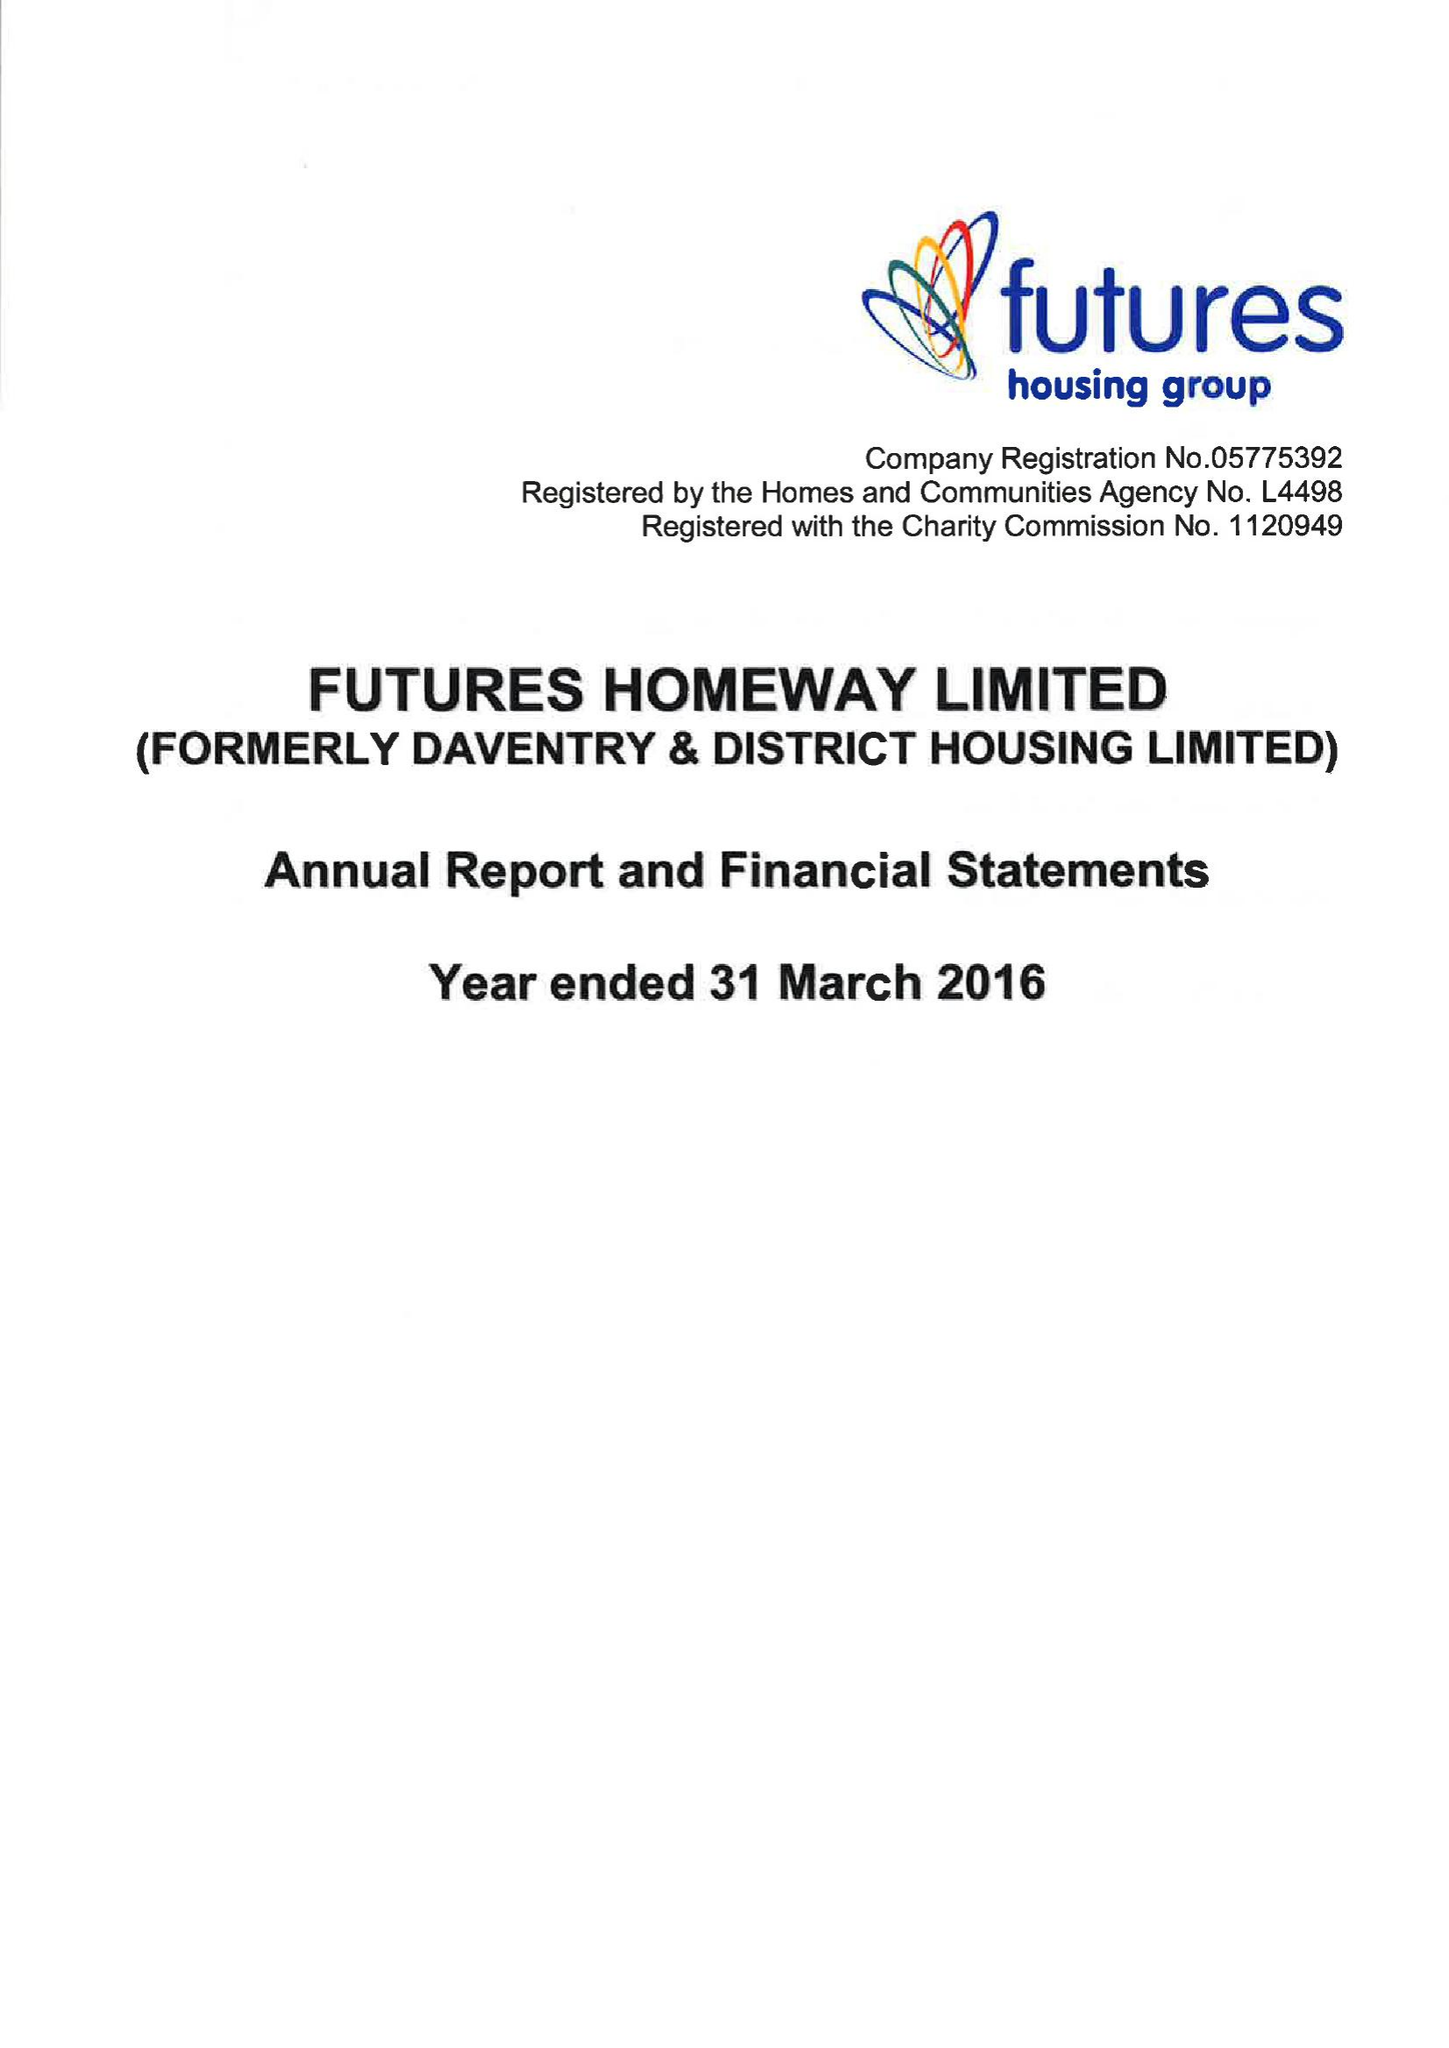What is the value for the charity_number?
Answer the question using a single word or phrase. 1120949 